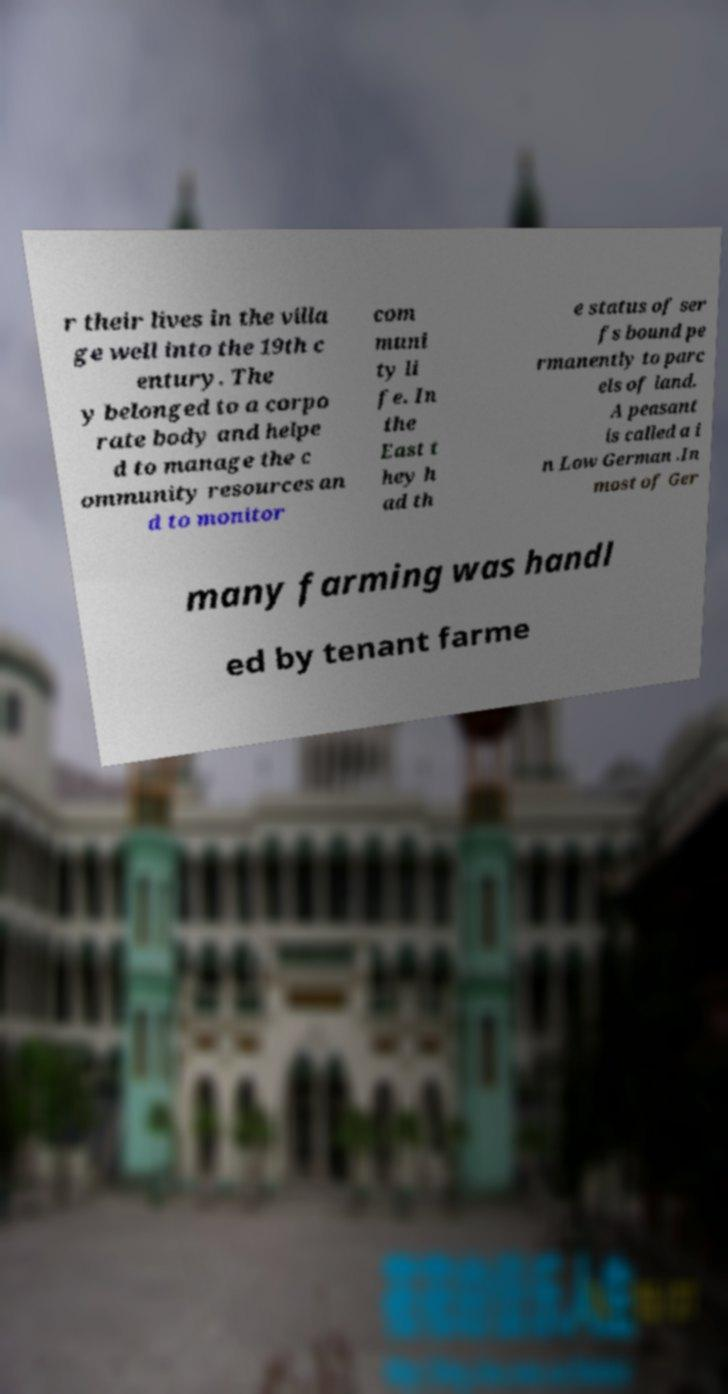Can you read and provide the text displayed in the image?This photo seems to have some interesting text. Can you extract and type it out for me? r their lives in the villa ge well into the 19th c entury. The y belonged to a corpo rate body and helpe d to manage the c ommunity resources an d to monitor com muni ty li fe. In the East t hey h ad th e status of ser fs bound pe rmanently to parc els of land. A peasant is called a i n Low German .In most of Ger many farming was handl ed by tenant farme 